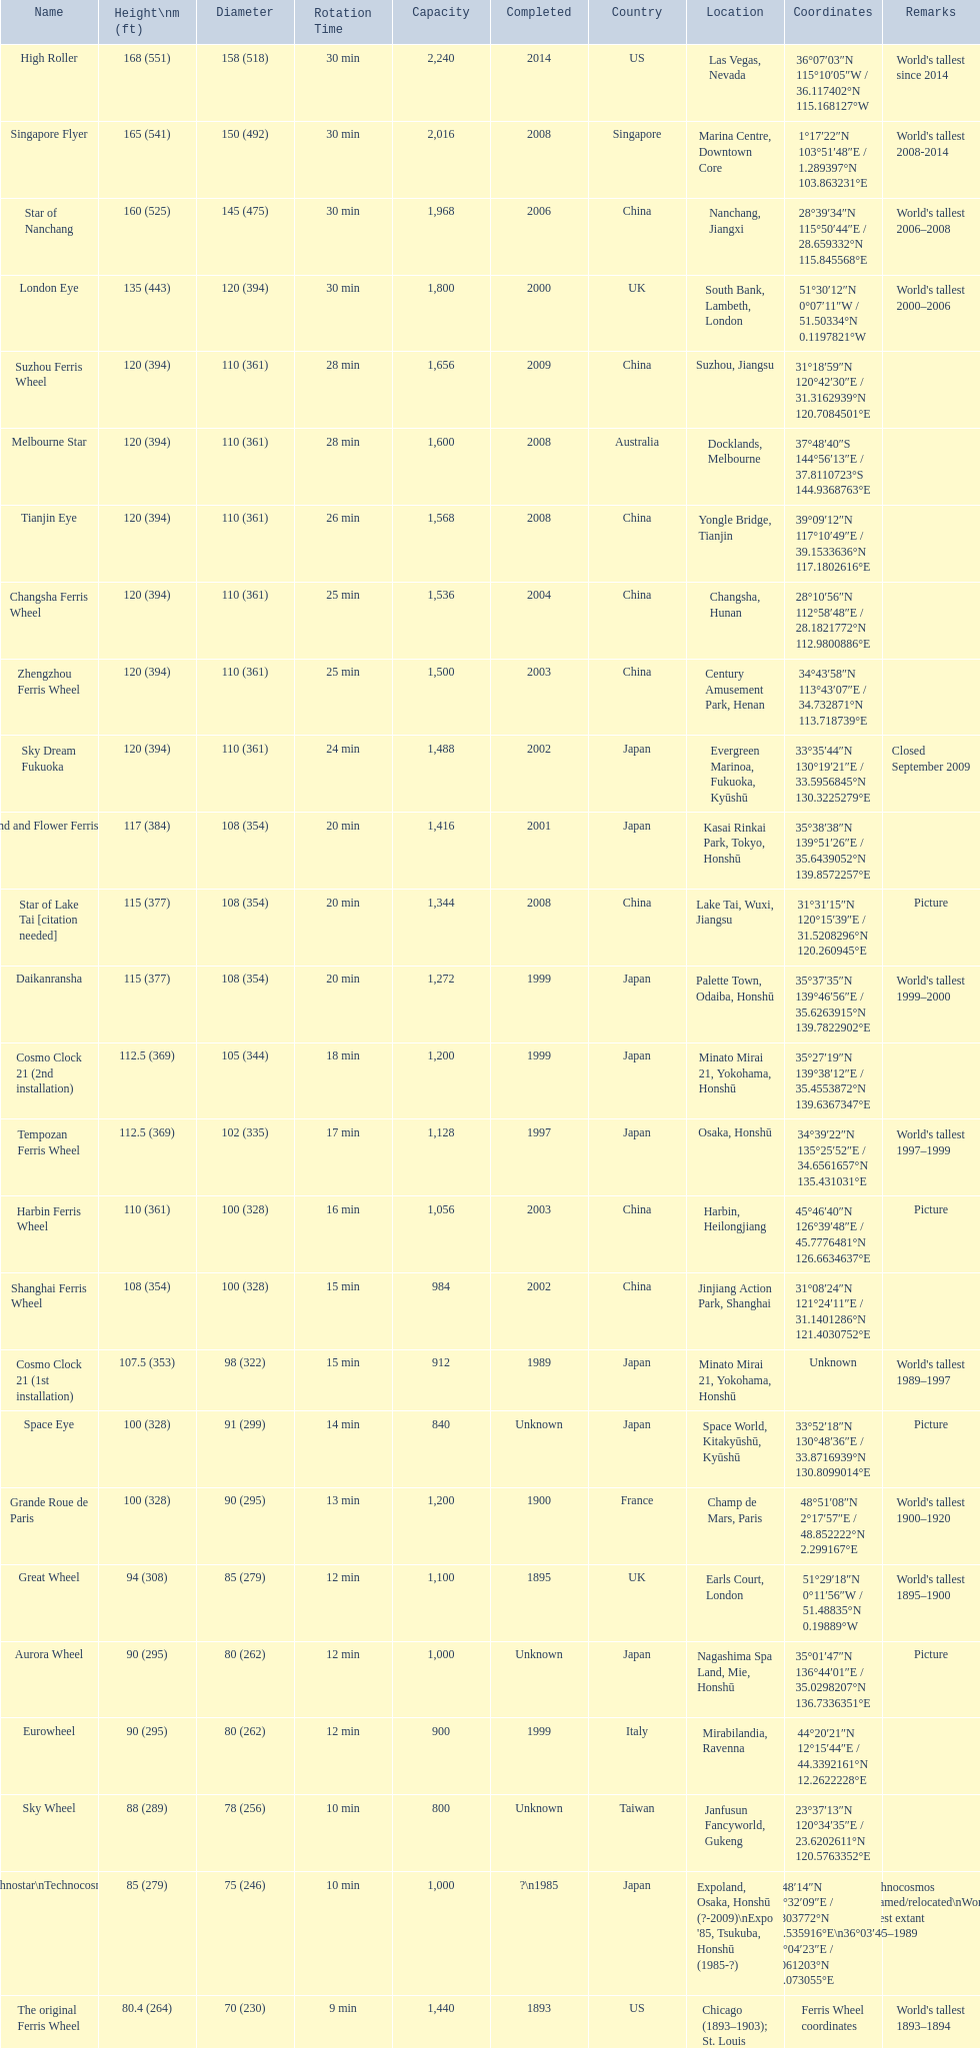Where was the original tallest roller coster built? Chicago. 